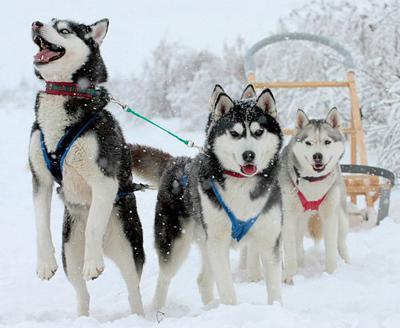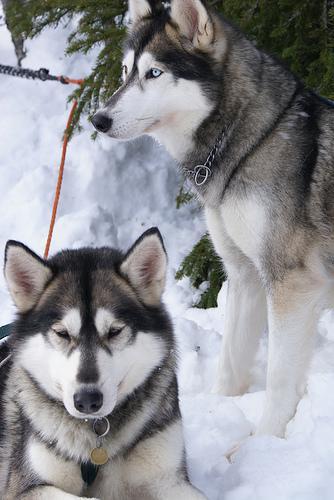The first image is the image on the left, the second image is the image on the right. For the images shown, is this caption "One of the images contains one Husky dog and the other image contains two Husky dogs." true? Answer yes or no. No. The first image is the image on the left, the second image is the image on the right. Given the left and right images, does the statement "One image features a dog sitting upright to the right of a dog in a reclining pose, and the other image includes a dog with snow on its fur." hold true? Answer yes or no. Yes. 